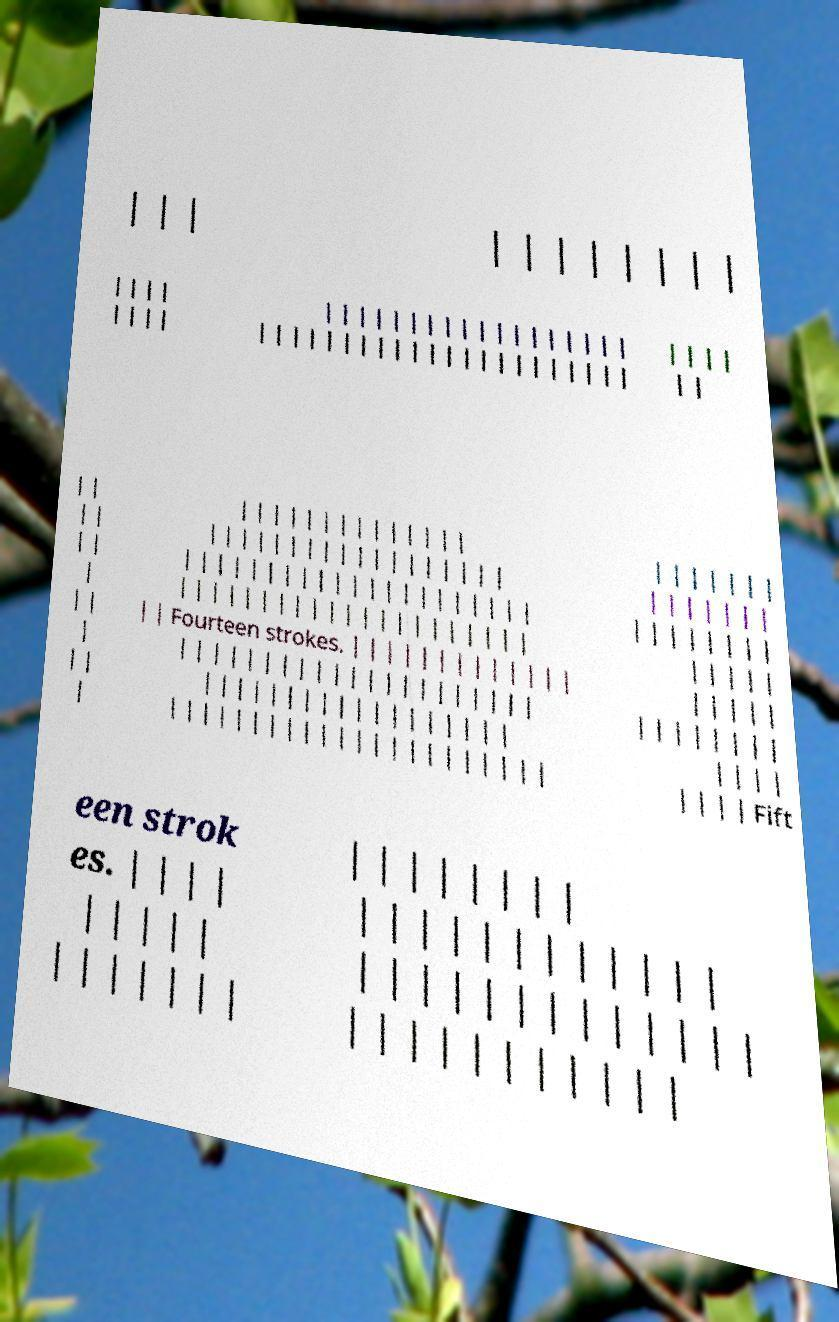For documentation purposes, I need the text within this image transcribed. Could you provide that? | | | | | | | | | | | | | | | | | | | | | | | | | | | | | | | | | | | | | | | | | | | | | | | | | | | | | | | | | | | | | | | | | | | | | | | | | | | | | | | | | | | | | | | | | | | | | | | | | | | | | | | | | | | | | | | | | | | | | | | | | | | | | | | | | | | | | | | | | | | | | | | | | | | | | | | | | | Fourteen strokes. | | | | | | | | | | | | | | | | | | | | | | | | | | | | | | | | | | | | | | | | | | | | | | | | | | | | | | | | | | | | | | | | | | | | | | | | | | | | | | | | | | | | | | | | | | | | | | | | | | | | | | | | | | | | | | | | | | | | | | | | | | Fift een strok es. | | | | | | | | | | | | | | | | | | | | | | | | | | | | | | | | | | | | | | | | | | | | | | | | | | | | | | | | | | | | 